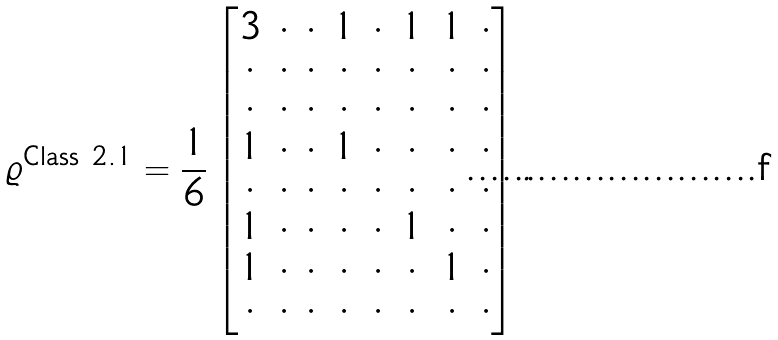<formula> <loc_0><loc_0><loc_500><loc_500>\varrho ^ { \text {Class 2.1} } = \frac { 1 } { 6 } \begin{bmatrix} 3 & \cdot & \cdot & 1 & \cdot & 1 & 1 & \cdot \\ \cdot & \cdot & \cdot & \cdot & \cdot & \cdot & \cdot & \cdot \\ \cdot & \cdot & \cdot & \cdot & \cdot & \cdot & \cdot & \cdot \\ 1 & \cdot & \cdot & 1 & \cdot & \cdot & \cdot & \cdot \\ \cdot & \cdot & \cdot & \cdot & \cdot & \cdot & \cdot & \cdot \\ 1 & \cdot & \cdot & \cdot & \cdot & 1 & \cdot & \cdot \\ 1 & \cdot & \cdot & \cdot & \cdot & \cdot & 1 & \cdot \\ \cdot & \cdot & \cdot & \cdot & \cdot & \cdot & \cdot & \cdot \end{bmatrix} .</formula> 